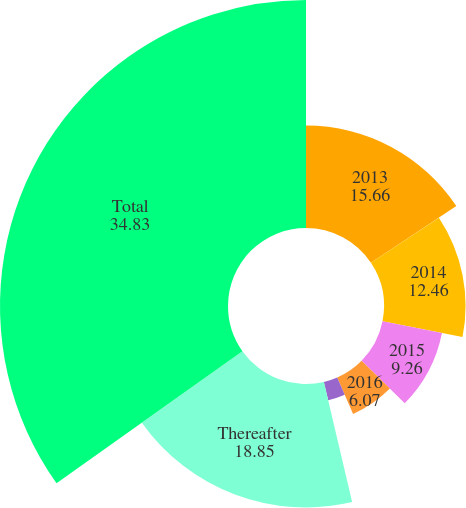Convert chart to OTSL. <chart><loc_0><loc_0><loc_500><loc_500><pie_chart><fcel>2013<fcel>2014<fcel>2015<fcel>2016<fcel>2017<fcel>Thereafter<fcel>Total<nl><fcel>15.66%<fcel>12.46%<fcel>9.26%<fcel>6.07%<fcel>2.87%<fcel>18.85%<fcel>34.83%<nl></chart> 